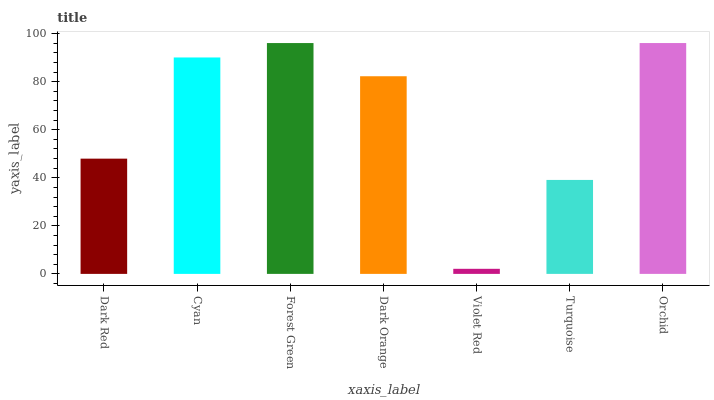Is Cyan the minimum?
Answer yes or no. No. Is Cyan the maximum?
Answer yes or no. No. Is Cyan greater than Dark Red?
Answer yes or no. Yes. Is Dark Red less than Cyan?
Answer yes or no. Yes. Is Dark Red greater than Cyan?
Answer yes or no. No. Is Cyan less than Dark Red?
Answer yes or no. No. Is Dark Orange the high median?
Answer yes or no. Yes. Is Dark Orange the low median?
Answer yes or no. Yes. Is Dark Red the high median?
Answer yes or no. No. Is Turquoise the low median?
Answer yes or no. No. 